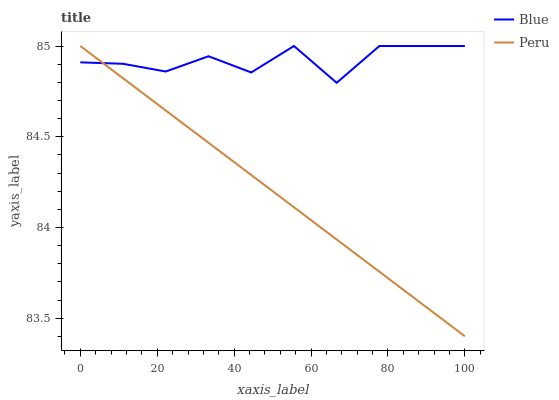Does Peru have the minimum area under the curve?
Answer yes or no. Yes. Does Blue have the maximum area under the curve?
Answer yes or no. Yes. Does Peru have the maximum area under the curve?
Answer yes or no. No. Is Peru the smoothest?
Answer yes or no. Yes. Is Blue the roughest?
Answer yes or no. Yes. Is Peru the roughest?
Answer yes or no. No. Does Peru have the lowest value?
Answer yes or no. Yes. Does Peru have the highest value?
Answer yes or no. Yes. Does Peru intersect Blue?
Answer yes or no. Yes. Is Peru less than Blue?
Answer yes or no. No. Is Peru greater than Blue?
Answer yes or no. No. 